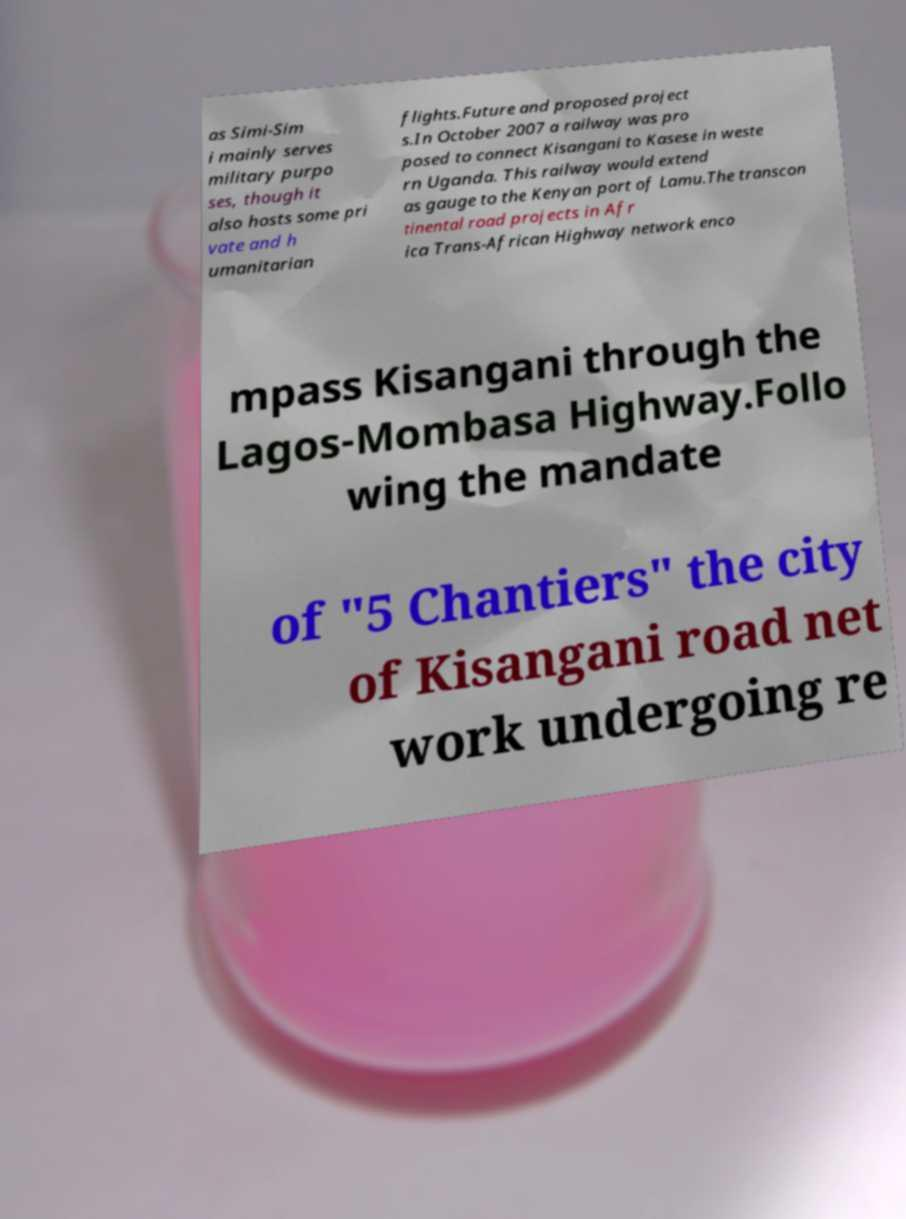Can you accurately transcribe the text from the provided image for me? as Simi-Sim i mainly serves military purpo ses, though it also hosts some pri vate and h umanitarian flights.Future and proposed project s.In October 2007 a railway was pro posed to connect Kisangani to Kasese in weste rn Uganda. This railway would extend as gauge to the Kenyan port of Lamu.The transcon tinental road projects in Afr ica Trans-African Highway network enco mpass Kisangani through the Lagos-Mombasa Highway.Follo wing the mandate of "5 Chantiers" the city of Kisangani road net work undergoing re 